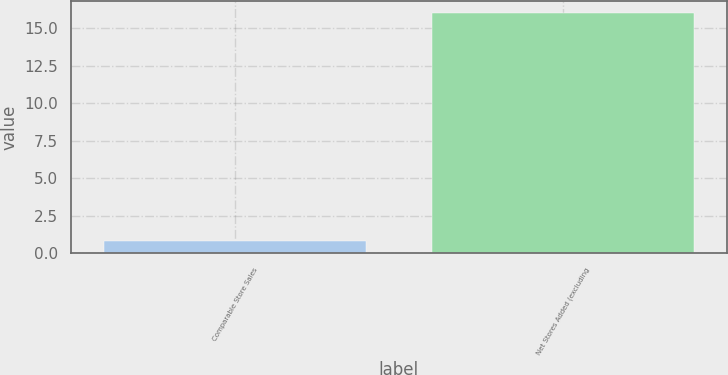<chart> <loc_0><loc_0><loc_500><loc_500><bar_chart><fcel>Comparable Store Sales<fcel>Net Stores Added (excluding<nl><fcel>0.8<fcel>16<nl></chart> 